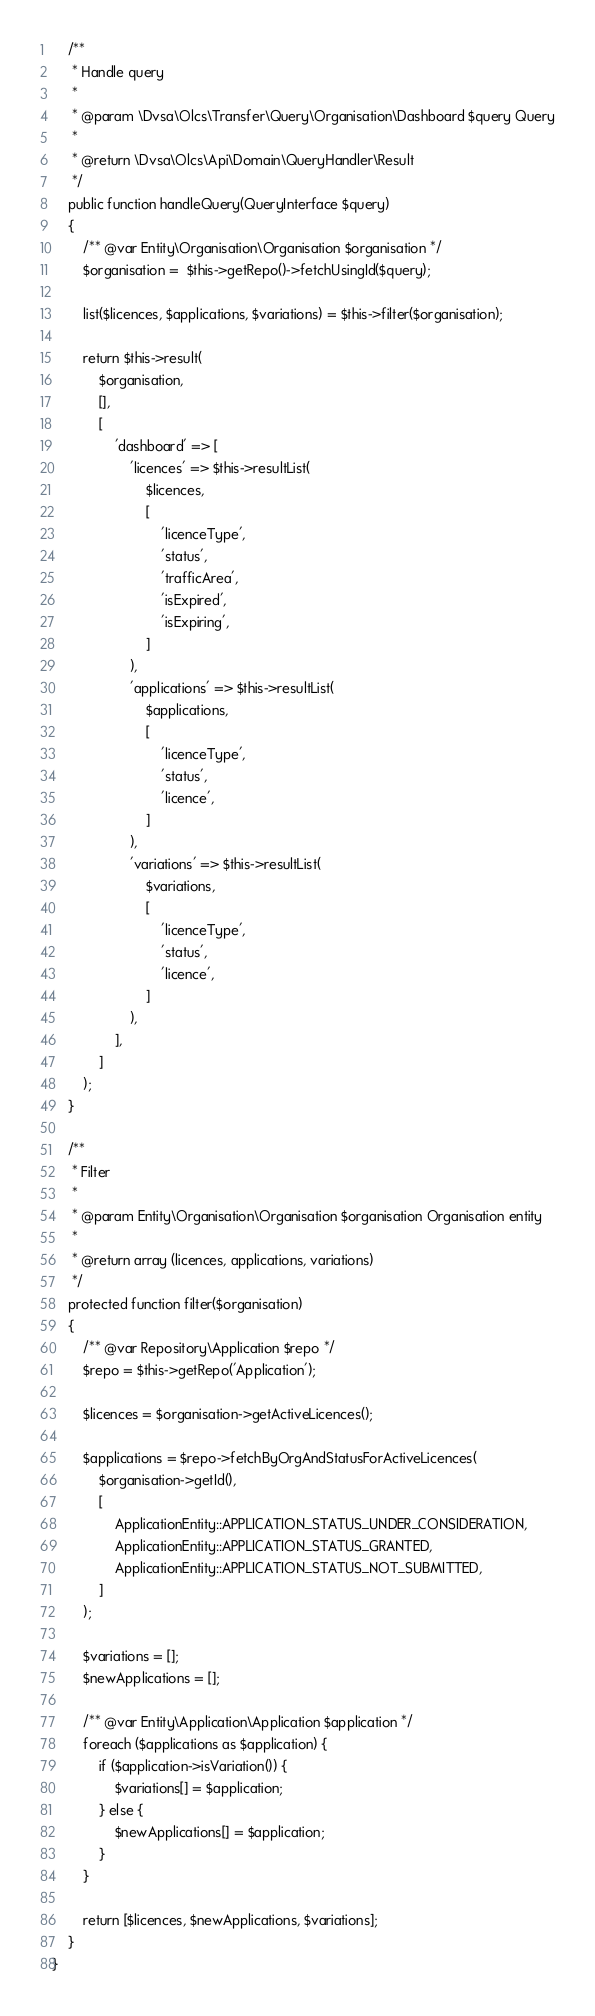<code> <loc_0><loc_0><loc_500><loc_500><_PHP_>    /**
     * Handle query
     *
     * @param \Dvsa\Olcs\Transfer\Query\Organisation\Dashboard $query Query
     *
     * @return \Dvsa\Olcs\Api\Domain\QueryHandler\Result
     */
    public function handleQuery(QueryInterface $query)
    {
        /** @var Entity\Organisation\Organisation $organisation */
        $organisation =  $this->getRepo()->fetchUsingId($query);

        list($licences, $applications, $variations) = $this->filter($organisation);

        return $this->result(
            $organisation,
            [],
            [
                'dashboard' => [
                    'licences' => $this->resultList(
                        $licences,
                        [
                            'licenceType',
                            'status',
                            'trafficArea',
                            'isExpired',
                            'isExpiring',
                        ]
                    ),
                    'applications' => $this->resultList(
                        $applications,
                        [
                            'licenceType',
                            'status',
                            'licence',
                        ]
                    ),
                    'variations' => $this->resultList(
                        $variations,
                        [
                            'licenceType',
                            'status',
                            'licence',
                        ]
                    ),
                ],
            ]
        );
    }

    /**
     * Filter
     *
     * @param Entity\Organisation\Organisation $organisation Organisation entity
     *
     * @return array (licences, applications, variations)
     */
    protected function filter($organisation)
    {
        /** @var Repository\Application $repo */
        $repo = $this->getRepo('Application');

        $licences = $organisation->getActiveLicences();

        $applications = $repo->fetchByOrgAndStatusForActiveLicences(
            $organisation->getId(),
            [
                ApplicationEntity::APPLICATION_STATUS_UNDER_CONSIDERATION,
                ApplicationEntity::APPLICATION_STATUS_GRANTED,
                ApplicationEntity::APPLICATION_STATUS_NOT_SUBMITTED,
            ]
        );

        $variations = [];
        $newApplications = [];

        /** @var Entity\Application\Application $application */
        foreach ($applications as $application) {
            if ($application->isVariation()) {
                $variations[] = $application;
            } else {
                $newApplications[] = $application;
            }
        }

        return [$licences, $newApplications, $variations];
    }
}
</code> 